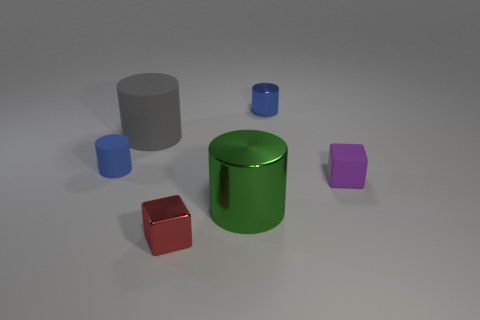Subtract all large matte cylinders. How many cylinders are left? 3 Subtract all blue spheres. How many blue cylinders are left? 2 Subtract all gray cylinders. How many cylinders are left? 3 Add 3 purple objects. How many objects exist? 9 Subtract all brown cylinders. Subtract all cyan balls. How many cylinders are left? 4 Subtract all cylinders. How many objects are left? 2 Subtract 0 brown blocks. How many objects are left? 6 Subtract all tiny yellow cylinders. Subtract all gray rubber cylinders. How many objects are left? 5 Add 4 small blue rubber objects. How many small blue rubber objects are left? 5 Add 4 red cylinders. How many red cylinders exist? 4 